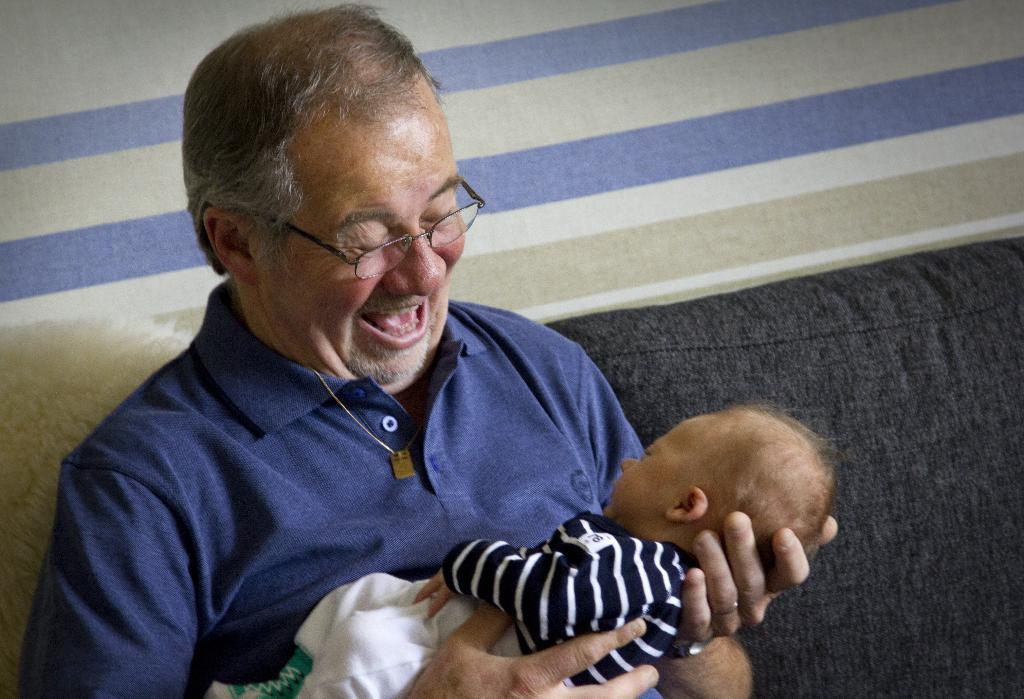Who is present in the image? There is a man in the image. What is the man doing in the image? The man is holding a baby. Where is the man sitting in the image? The man is sitting on a couch. What expression does the man have in the image? The man is smiling. What can be seen at the top of the image? There is a wall visible at the top of the image. What type of cloth is being used to power the industry in the image? There is no mention of an industry or cloth in the image; it features a man holding a baby while sitting on a couch. 